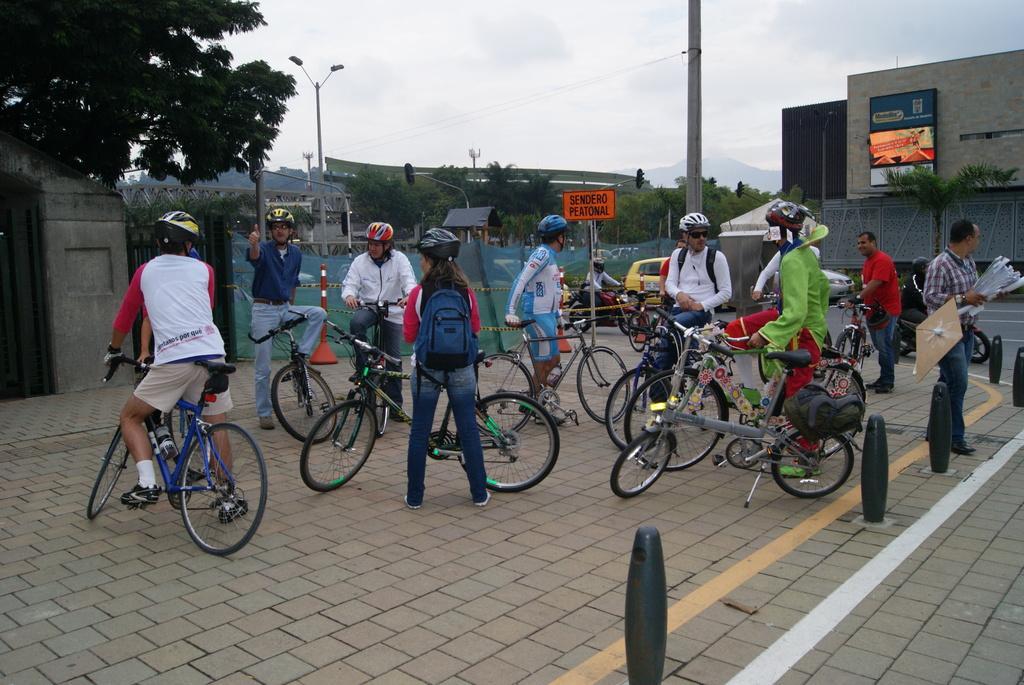In one or two sentences, can you explain what this image depicts? In the center of the image we can see many persons on the cycles. In the background there is a tree, buildings, wall, nets, trees, poles, sky and clouds. 